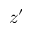<formula> <loc_0><loc_0><loc_500><loc_500>z ^ { \prime }</formula> 